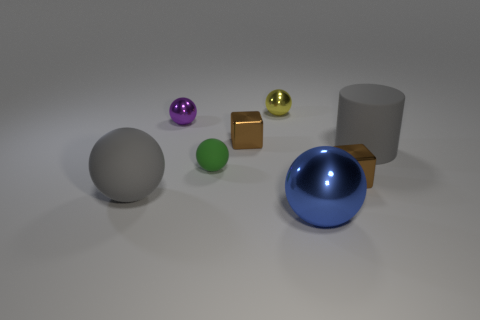There is a tiny metallic thing that is on the left side of the yellow metallic ball and in front of the small purple metal object; what color is it?
Provide a succinct answer. Brown. There is a gray object that is to the right of the big rubber ball; what material is it?
Keep it short and to the point. Rubber. How many other green objects are the same shape as the tiny green object?
Your answer should be compact. 0. Do the rubber cylinder and the big rubber ball have the same color?
Your response must be concise. Yes. What is the cube that is to the left of the brown metallic cube that is in front of the brown thing behind the gray cylinder made of?
Make the answer very short. Metal. There is a tiny purple shiny sphere; are there any gray rubber objects in front of it?
Your answer should be very brief. Yes. The purple thing that is the same size as the green rubber thing is what shape?
Your response must be concise. Sphere. Does the small green sphere have the same material as the yellow object?
Give a very brief answer. No. What number of shiny things are green spheres or yellow balls?
Offer a terse response. 1. There is a large object that is the same color as the big rubber sphere; what is its shape?
Provide a short and direct response. Cylinder. 